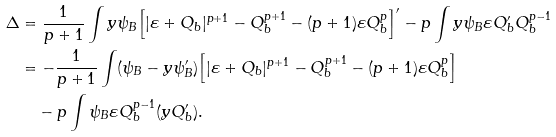Convert formula to latex. <formula><loc_0><loc_0><loc_500><loc_500>\Delta & = \frac { 1 } { p + 1 } \int y \psi _ { B } \Big { [ } | \varepsilon + Q _ { b } | ^ { p + 1 } - Q _ { b } ^ { p + 1 } - ( p + 1 ) \varepsilon Q _ { b } ^ { p } \Big { ] } ^ { \prime } - p \int y \psi _ { B } \varepsilon Q _ { b } ^ { \prime } Q _ { b } ^ { p - 1 } \\ & = - \frac { 1 } { p + 1 } \int ( \psi _ { B } - y \psi _ { B } ^ { \prime } ) \Big { [ } | \varepsilon + Q _ { b } | ^ { p + 1 } - Q _ { b } ^ { p + 1 } - ( p + 1 ) \varepsilon Q _ { b } ^ { p } \Big { ] } \\ & \quad - p \int \psi _ { B } \varepsilon Q _ { b } ^ { p - 1 } ( y Q _ { b } ^ { \prime } ) .</formula> 